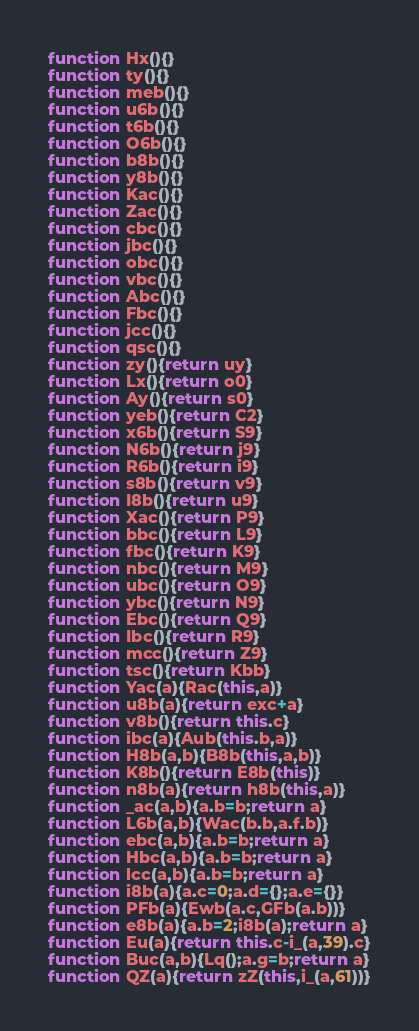<code> <loc_0><loc_0><loc_500><loc_500><_JavaScript_>function Hx(){}
function ty(){}
function meb(){}
function u6b(){}
function t6b(){}
function O6b(){}
function b8b(){}
function y8b(){}
function Kac(){}
function Zac(){}
function cbc(){}
function jbc(){}
function obc(){}
function vbc(){}
function Abc(){}
function Fbc(){}
function jcc(){}
function qsc(){}
function zy(){return uy}
function Lx(){return o0}
function Ay(){return s0}
function yeb(){return C2}
function x6b(){return S9}
function N6b(){return j9}
function R6b(){return i9}
function s8b(){return v9}
function I8b(){return u9}
function Xac(){return P9}
function bbc(){return L9}
function fbc(){return K9}
function nbc(){return M9}
function ubc(){return O9}
function ybc(){return N9}
function Ebc(){return Q9}
function Ibc(){return R9}
function mcc(){return Z9}
function tsc(){return Kbb}
function Yac(a){Rac(this,a)}
function u8b(a){return exc+a}
function v8b(){return this.c}
function ibc(a){Aub(this.b,a)}
function H8b(a,b){B8b(this,a,b)}
function K8b(){return E8b(this)}
function n8b(a){return h8b(this,a)}
function _ac(a,b){a.b=b;return a}
function L6b(a,b){Wac(b.b,a.f.b)}
function ebc(a,b){a.b=b;return a}
function Hbc(a,b){a.b=b;return a}
function lcc(a,b){a.b=b;return a}
function i8b(a){a.c=0;a.d={};a.e={}}
function PFb(a){Ewb(a.c,GFb(a.b))}
function e8b(a){a.b=2;i8b(a);return a}
function Eu(a){return this.c-i_(a,39).c}
function Buc(a,b){Lq();a.g=b;return a}
function QZ(a){return zZ(this,i_(a,61))}</code> 